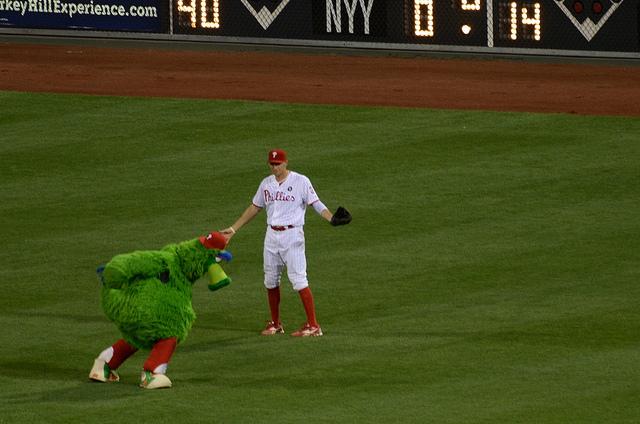Is the player standing?
Give a very brief answer. Yes. What is on the field with the player?
Give a very brief answer. Mascot. What is the generic term for the green fuzzy animal on the field?
Give a very brief answer. Mascot. Is this man a professional athlete?
Quick response, please. Yes. What sport is being played?
Be succinct. Baseball. 